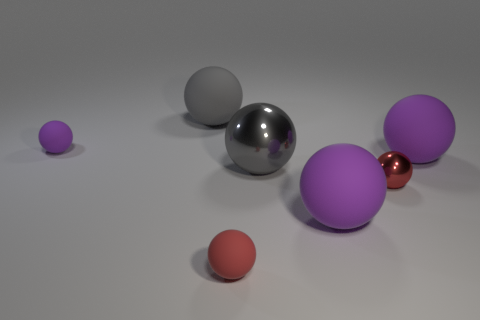Subtract all large gray shiny spheres. How many spheres are left? 6 Subtract all purple spheres. How many spheres are left? 4 Add 1 rubber objects. How many objects exist? 8 Subtract 2 balls. How many balls are left? 5 Subtract all brown spheres. Subtract all cyan cylinders. How many spheres are left? 7 Subtract all blue cylinders. How many red spheres are left? 2 Subtract all red matte balls. Subtract all red things. How many objects are left? 4 Add 4 big objects. How many big objects are left? 8 Add 5 small cyan metallic objects. How many small cyan metallic objects exist? 5 Subtract 0 cyan cylinders. How many objects are left? 7 